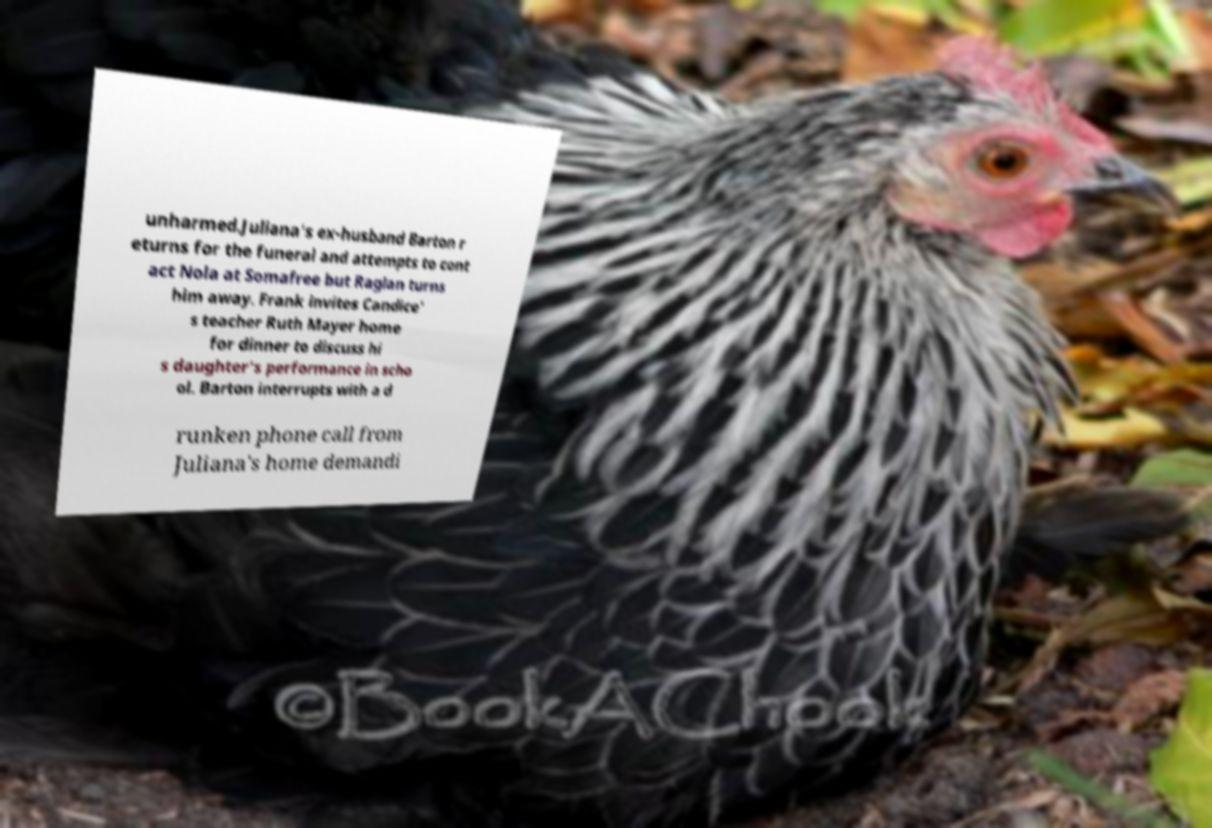I need the written content from this picture converted into text. Can you do that? unharmed.Juliana's ex-husband Barton r eturns for the funeral and attempts to cont act Nola at Somafree but Raglan turns him away. Frank invites Candice' s teacher Ruth Mayer home for dinner to discuss hi s daughter's performance in scho ol. Barton interrupts with a d runken phone call from Juliana's home demandi 